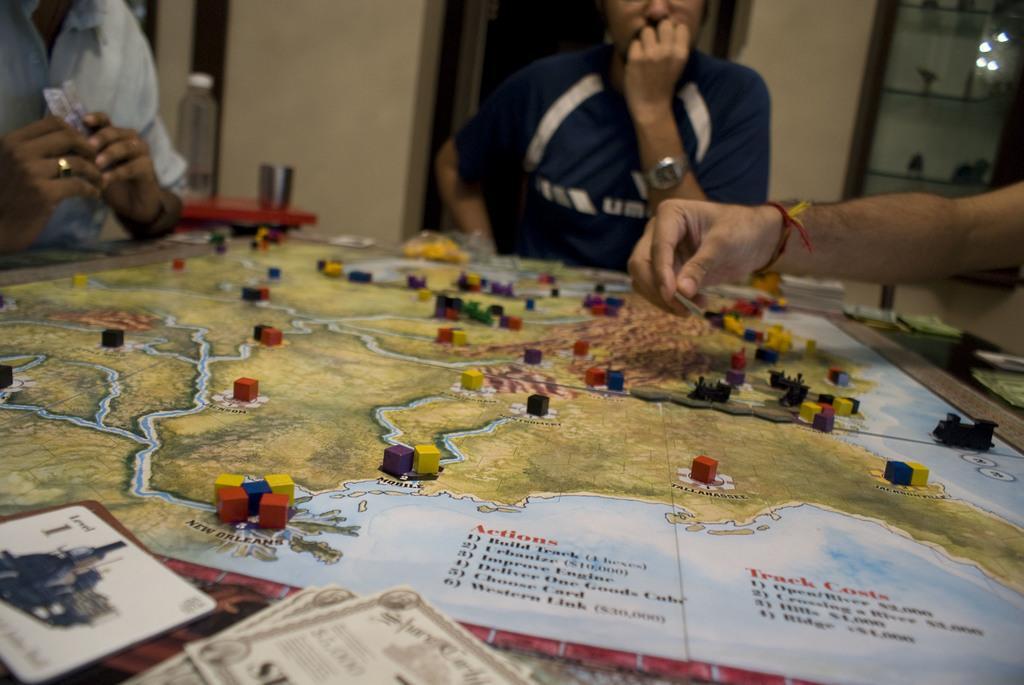How would you summarize this image in a sentence or two? This picture is consists of board game in the image and there are people around the board and there is a showcase and a door in the background area of the image, there is a water bottle and a glass in the image. 